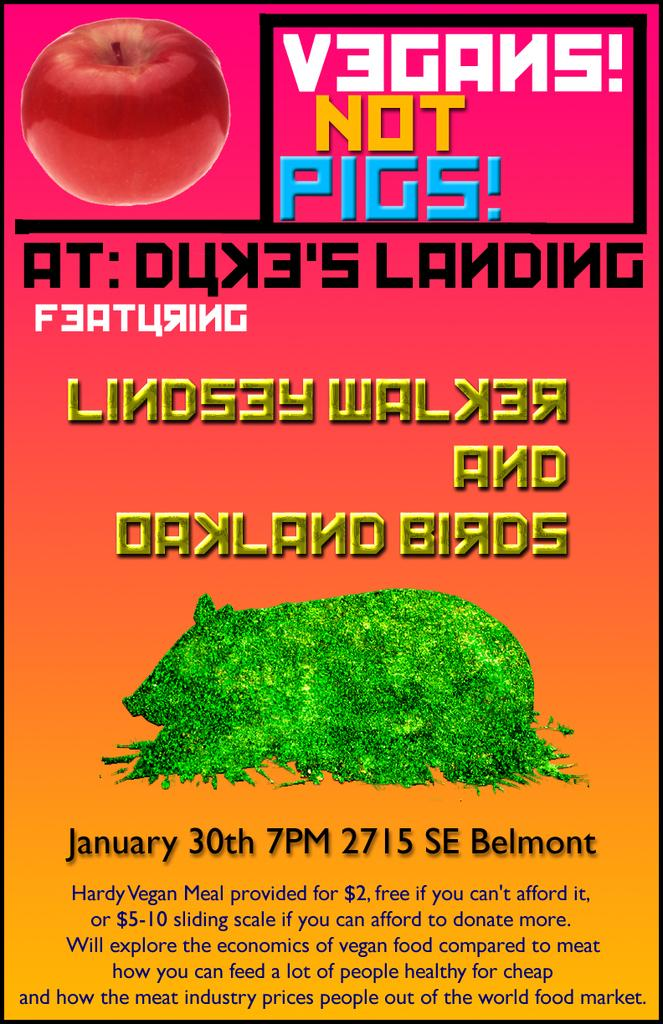What is featured in the image? There is a poster in the image. What can be found on the poster? The poster contains text and an apple. What type of toy is depicted on the poster? There is no toy depicted on the poster; it features text and an apple. What type of border surrounds the poster in the image? There is no information about a border surrounding the poster in the image. 